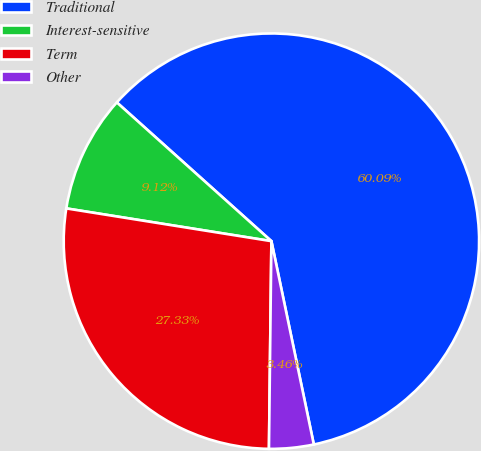Convert chart. <chart><loc_0><loc_0><loc_500><loc_500><pie_chart><fcel>Traditional<fcel>Interest-sensitive<fcel>Term<fcel>Other<nl><fcel>60.08%<fcel>9.12%<fcel>27.33%<fcel>3.46%<nl></chart> 